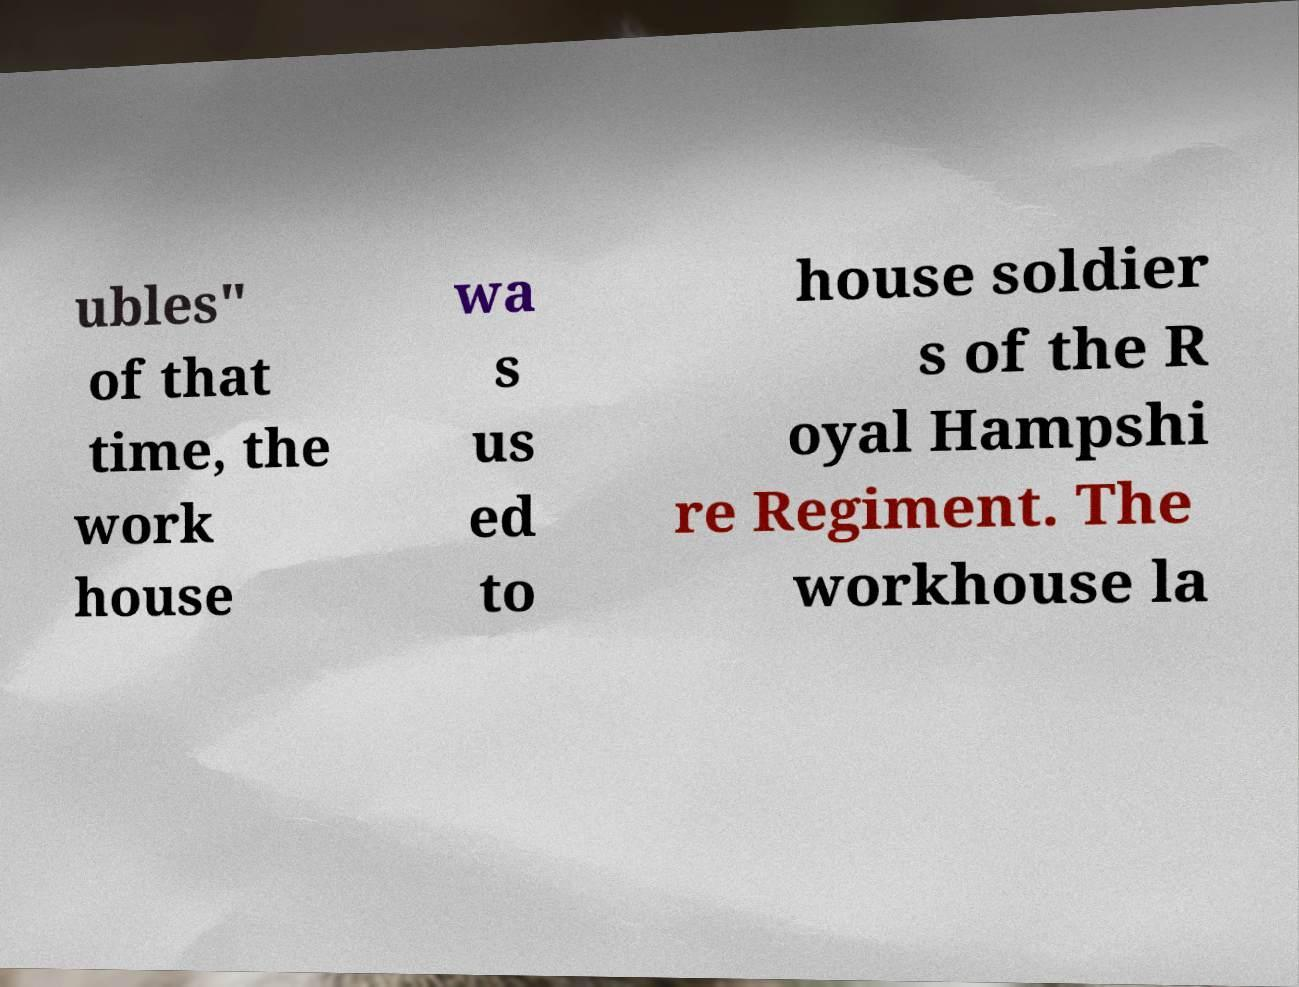I need the written content from this picture converted into text. Can you do that? ubles" of that time, the work house wa s us ed to house soldier s of the R oyal Hampshi re Regiment. The workhouse la 